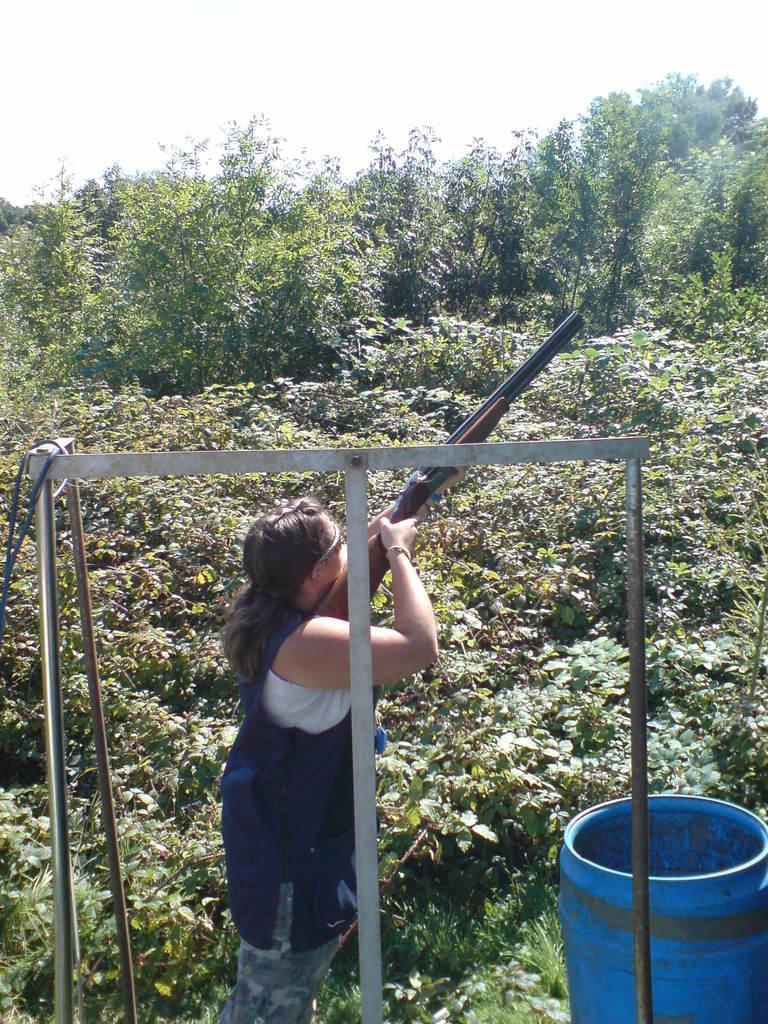Could you give a brief overview of what you see in this image? In the picture we can see a woman standing on the grass surface and holding and gun and looking up and behind her we can see a stand and in front of her we can see, full of plants and in the background also we can see plants, trees and sky. 